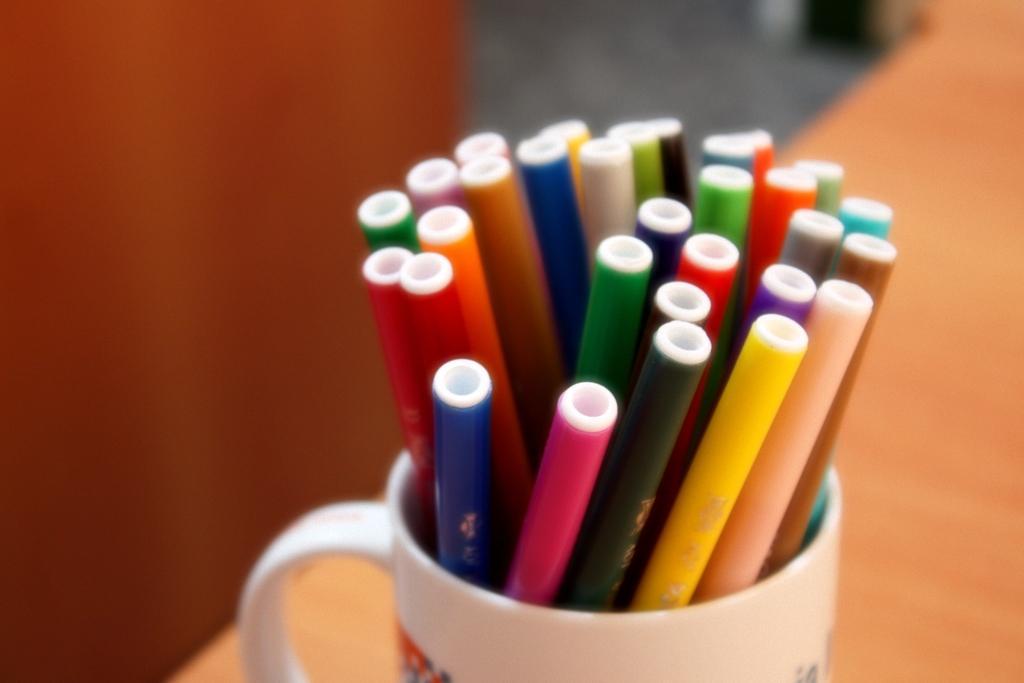In one or two sentences, can you explain what this image depicts? In the image there are sketch pens kept in a cup. 